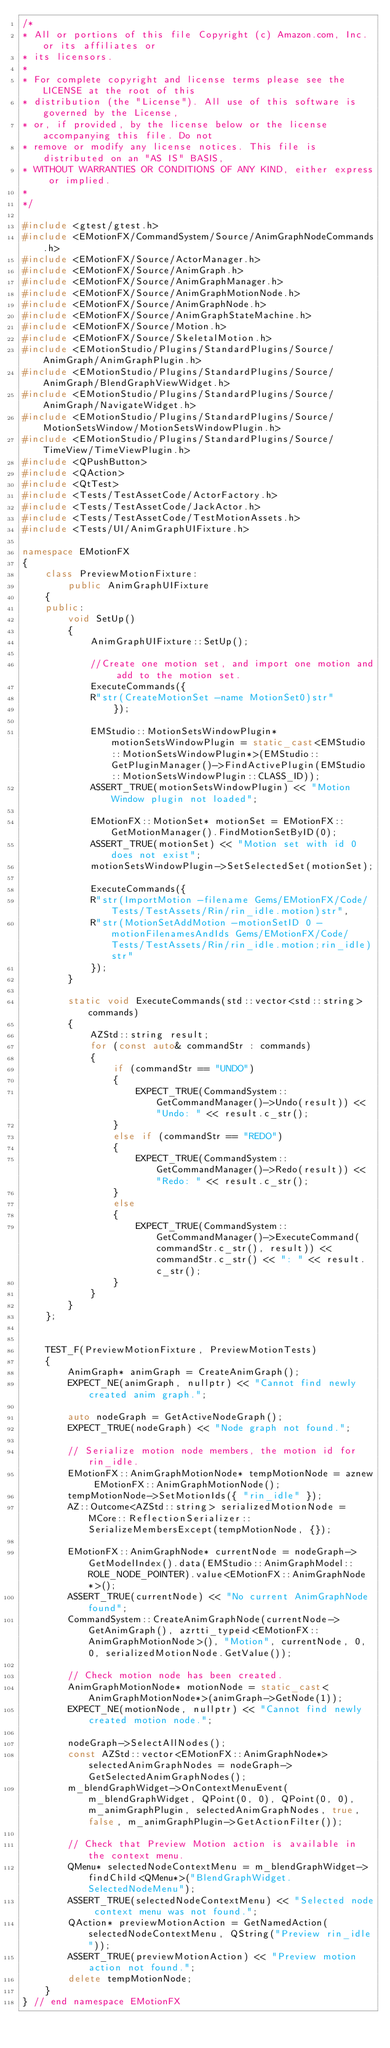Convert code to text. <code><loc_0><loc_0><loc_500><loc_500><_C++_>/*
* All or portions of this file Copyright (c) Amazon.com, Inc. or its affiliates or
* its licensors.
*
* For complete copyright and license terms please see the LICENSE at the root of this
* distribution (the "License"). All use of this software is governed by the License,
* or, if provided, by the license below or the license accompanying this file. Do not
* remove or modify any license notices. This file is distributed on an "AS IS" BASIS,
* WITHOUT WARRANTIES OR CONDITIONS OF ANY KIND, either express or implied.
*
*/

#include <gtest/gtest.h>
#include <EMotionFX/CommandSystem/Source/AnimGraphNodeCommands.h>
#include <EMotionFX/Source/ActorManager.h>
#include <EMotionFX/Source/AnimGraph.h>
#include <EMotionFX/Source/AnimGraphManager.h>
#include <EMotionFX/Source/AnimGraphMotionNode.h>
#include <EMotionFX/Source/AnimGraphNode.h>
#include <EMotionFX/Source/AnimGraphStateMachine.h>
#include <EMotionFX/Source/Motion.h>
#include <EMotionFX/Source/SkeletalMotion.h>
#include <EMotionStudio/Plugins/StandardPlugins/Source/AnimGraph/AnimGraphPlugin.h>
#include <EMotionStudio/Plugins/StandardPlugins/Source/AnimGraph/BlendGraphViewWidget.h>
#include <EMotionStudio/Plugins/StandardPlugins/Source/AnimGraph/NavigateWidget.h>
#include <EMotionStudio/Plugins/StandardPlugins/Source/MotionSetsWindow/MotionSetsWindowPlugin.h>
#include <EMotionStudio/Plugins/StandardPlugins/Source/TimeView/TimeViewPlugin.h>
#include <QPushButton>
#include <QAction>
#include <QtTest>
#include <Tests/TestAssetCode/ActorFactory.h>
#include <Tests/TestAssetCode/JackActor.h>
#include <Tests/TestAssetCode/TestMotionAssets.h>
#include <Tests/UI/AnimGraphUIFixture.h>

namespace EMotionFX
{   
    class PreviewMotionFixture:
        public AnimGraphUIFixture
    {
    public:
        void SetUp()
        {
            AnimGraphUIFixture::SetUp();
            
            //Create one motion set, and import one motion and add to the motion set.
            ExecuteCommands({
            R"str(CreateMotionSet -name MotionSet0)str"
                });

            EMStudio::MotionSetsWindowPlugin* motionSetsWindowPlugin = static_cast<EMStudio::MotionSetsWindowPlugin*>(EMStudio::GetPluginManager()->FindActivePlugin(EMStudio::MotionSetsWindowPlugin::CLASS_ID));
            ASSERT_TRUE(motionSetsWindowPlugin) << "Motion Window plugin not loaded";

            EMotionFX::MotionSet* motionSet = EMotionFX::GetMotionManager().FindMotionSetByID(0);
            ASSERT_TRUE(motionSet) << "Motion set with id 0 does not exist";
            motionSetsWindowPlugin->SetSelectedSet(motionSet);

            ExecuteCommands({
            R"str(ImportMotion -filename Gems/EMotionFX/Code/Tests/TestAssets/Rin/rin_idle.motion)str",
            R"str(MotionSetAddMotion -motionSetID 0 -motionFilenamesAndIds Gems/EMotionFX/Code/Tests/TestAssets/Rin/rin_idle.motion;rin_idle)str"
            });
        }

        static void ExecuteCommands(std::vector<std::string> commands)
        {
            AZStd::string result;
            for (const auto& commandStr : commands)
            {
                if (commandStr == "UNDO")
                {
                    EXPECT_TRUE(CommandSystem::GetCommandManager()->Undo(result)) << "Undo: " << result.c_str();
                }
                else if (commandStr == "REDO")
                {
                    EXPECT_TRUE(CommandSystem::GetCommandManager()->Redo(result)) << "Redo: " << result.c_str();
                }
                else
                {
                    EXPECT_TRUE(CommandSystem::GetCommandManager()->ExecuteCommand(commandStr.c_str(), result)) << commandStr.c_str() << ": " << result.c_str();
                }
            }
        }
    };
    

    TEST_F(PreviewMotionFixture, PreviewMotionTests)
    {
        AnimGraph* animGraph = CreateAnimGraph();
        EXPECT_NE(animGraph, nullptr) << "Cannot find newly created anim graph.";

        auto nodeGraph = GetActiveNodeGraph();
        EXPECT_TRUE(nodeGraph) << "Node graph not found.";

        // Serialize motion node members, the motion id for rin_idle.
        EMotionFX::AnimGraphMotionNode* tempMotionNode = aznew EMotionFX::AnimGraphMotionNode();
        tempMotionNode->SetMotionIds({ "rin_idle" });
        AZ::Outcome<AZStd::string> serializedMotionNode = MCore::ReflectionSerializer::SerializeMembersExcept(tempMotionNode, {});
        
        EMotionFX::AnimGraphNode* currentNode = nodeGraph->GetModelIndex().data(EMStudio::AnimGraphModel::ROLE_NODE_POINTER).value<EMotionFX::AnimGraphNode*>();
        ASSERT_TRUE(currentNode) << "No current AnimGraphNode found";
        CommandSystem::CreateAnimGraphNode(currentNode->GetAnimGraph(), azrtti_typeid<EMotionFX::AnimGraphMotionNode>(), "Motion", currentNode, 0, 0, serializedMotionNode.GetValue());

        // Check motion node has been created.
        AnimGraphMotionNode* motionNode = static_cast<AnimGraphMotionNode*>(animGraph->GetNode(1));
        EXPECT_NE(motionNode, nullptr) << "Cannot find newly created motion node.";

        nodeGraph->SelectAllNodes();
        const AZStd::vector<EMotionFX::AnimGraphNode*> selectedAnimGraphNodes = nodeGraph->GetSelectedAnimGraphNodes();
        m_blendGraphWidget->OnContextMenuEvent(m_blendGraphWidget, QPoint(0, 0), QPoint(0, 0), m_animGraphPlugin, selectedAnimGraphNodes, true, false, m_animGraphPlugin->GetActionFilter());

        // Check that Preview Motion action is available in the context menu.
        QMenu* selectedNodeContextMenu = m_blendGraphWidget->findChild<QMenu*>("BlendGraphWidget.SelectedNodeMenu");
        ASSERT_TRUE(selectedNodeContextMenu) << "Selected node context menu was not found.";
        QAction* previewMotionAction = GetNamedAction(selectedNodeContextMenu, QString("Preview rin_idle"));
        ASSERT_TRUE(previewMotionAction) << "Preview motion action not found.";
        delete tempMotionNode;
    }
} // end namespace EMotionFX
</code> 